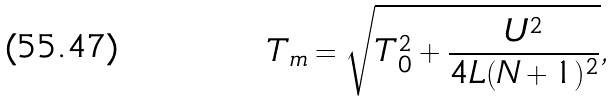Convert formula to latex. <formula><loc_0><loc_0><loc_500><loc_500>T _ { m } = \sqrt { T _ { 0 } ^ { 2 } + \frac { U ^ { 2 } } { 4 L ( N + 1 ) ^ { 2 } } } ,</formula> 